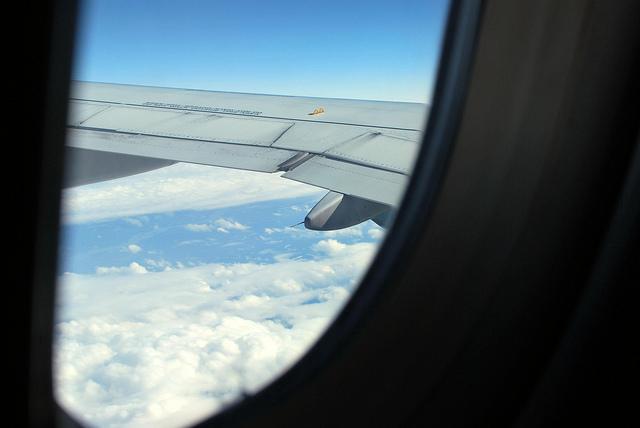Is the plane flying above the clouds?
Concise answer only. Yes. Is this the wing of a plane?
Write a very short answer. Yes. Are there birds in the photo?
Answer briefly. No. 